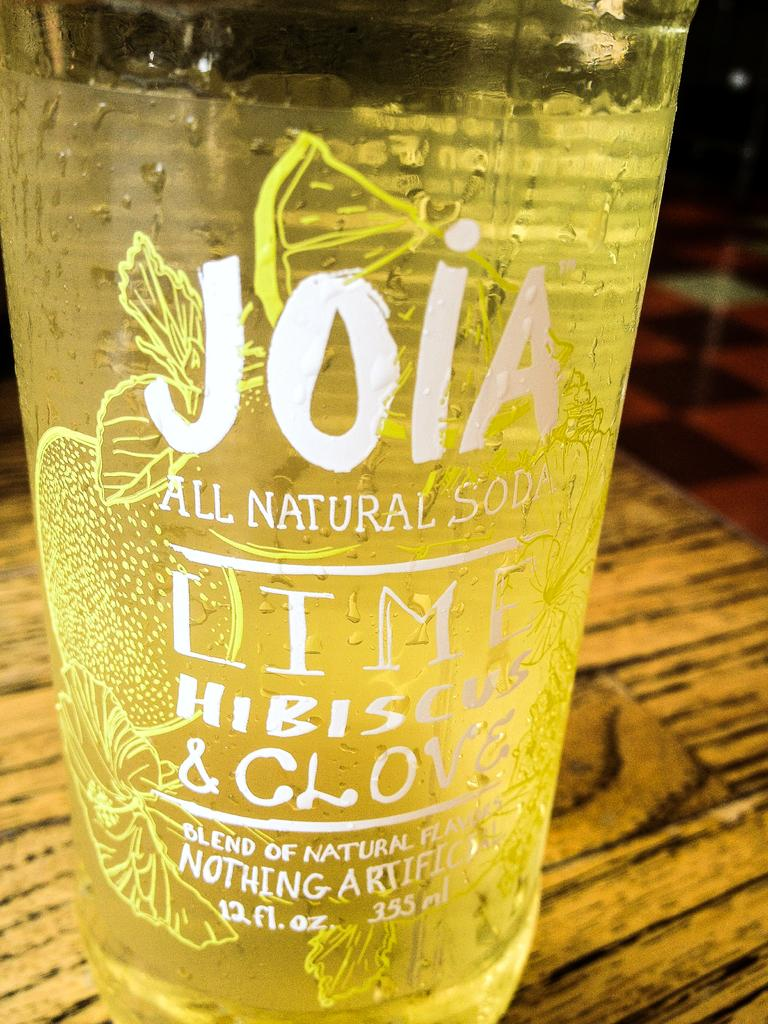<image>
Relay a brief, clear account of the picture shown. Joia all natural SOD drink, with a blend of natural flavors. 